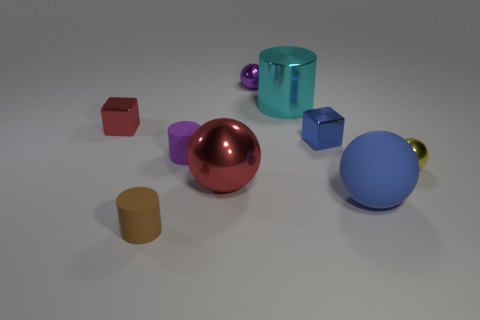Subtract all large blue rubber spheres. How many spheres are left? 3 Subtract all brown cylinders. How many cylinders are left? 2 Subtract 3 balls. How many balls are left? 1 Subtract all spheres. How many objects are left? 5 Subtract all blue cylinders. How many yellow balls are left? 1 Subtract all small blue shiny objects. Subtract all large metal objects. How many objects are left? 6 Add 1 purple balls. How many purple balls are left? 2 Add 7 small cylinders. How many small cylinders exist? 9 Subtract 0 purple blocks. How many objects are left? 9 Subtract all red spheres. Subtract all gray blocks. How many spheres are left? 3 